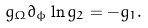<formula> <loc_0><loc_0><loc_500><loc_500>g _ { \Omega } \partial _ { \phi } \ln g _ { 2 } = - g _ { 1 } .</formula> 